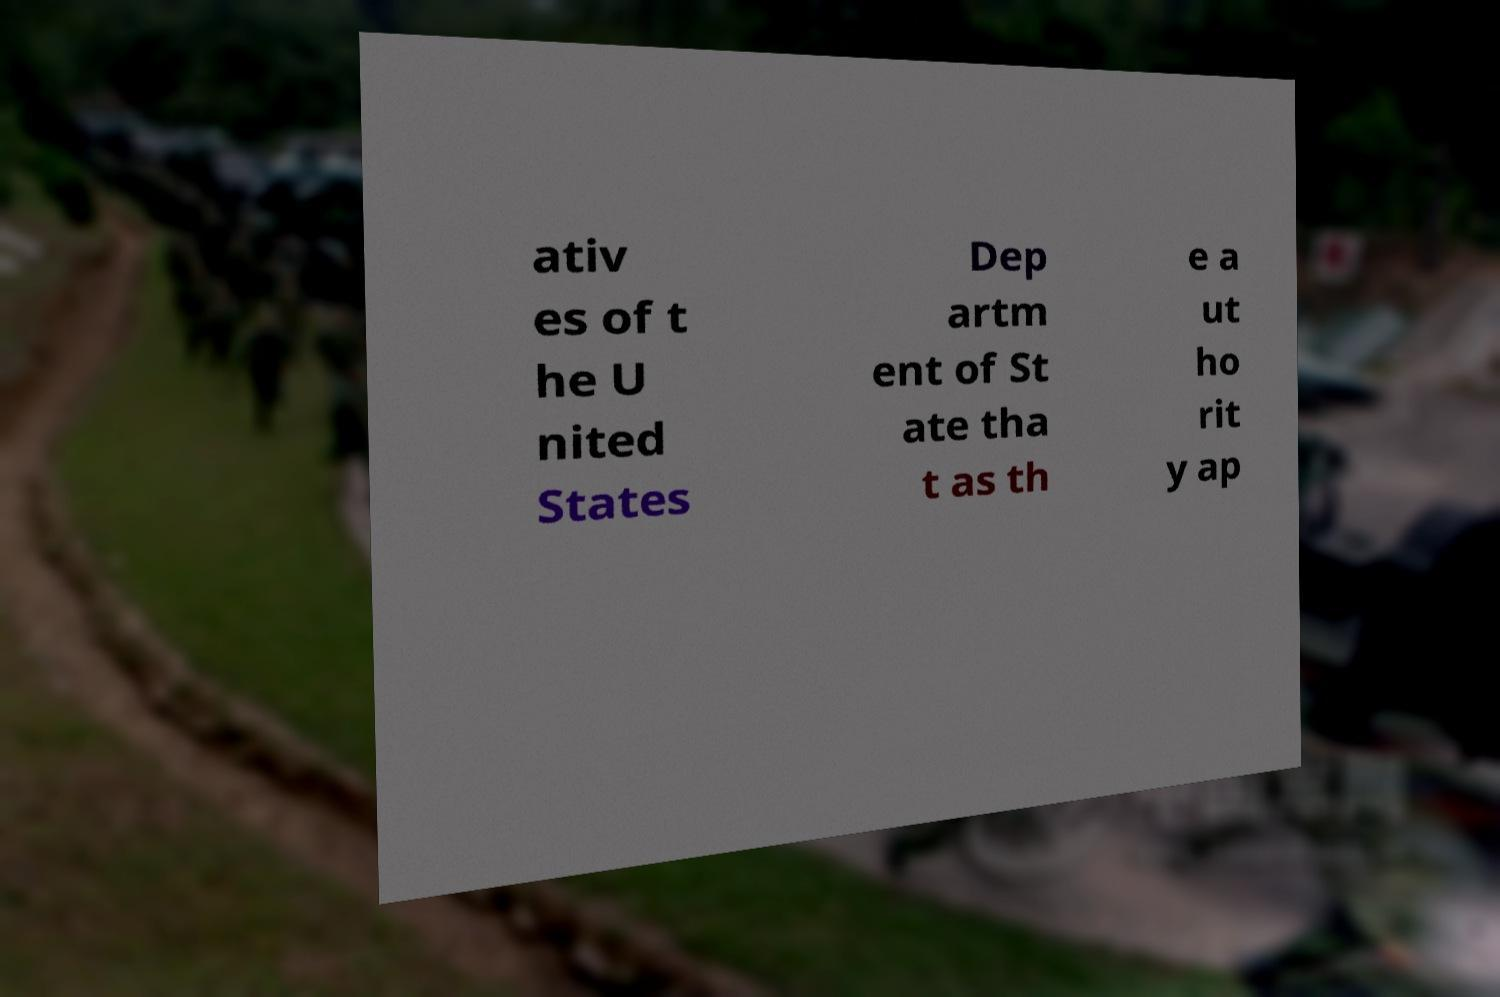Please read and relay the text visible in this image. What does it say? ativ es of t he U nited States Dep artm ent of St ate tha t as th e a ut ho rit y ap 